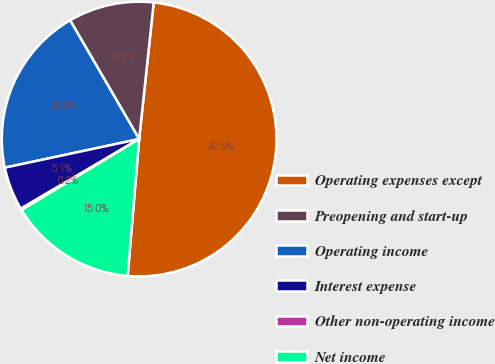<chart> <loc_0><loc_0><loc_500><loc_500><pie_chart><fcel>Operating expenses except<fcel>Preopening and start-up<fcel>Operating income<fcel>Interest expense<fcel>Other non-operating income<fcel>Net income<nl><fcel>49.64%<fcel>10.07%<fcel>19.96%<fcel>5.12%<fcel>0.18%<fcel>15.02%<nl></chart> 